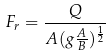Convert formula to latex. <formula><loc_0><loc_0><loc_500><loc_500>F _ { r } = \frac { Q } { A ( g \frac { A } { B } ) ^ { \frac { 1 } { 2 } } }</formula> 